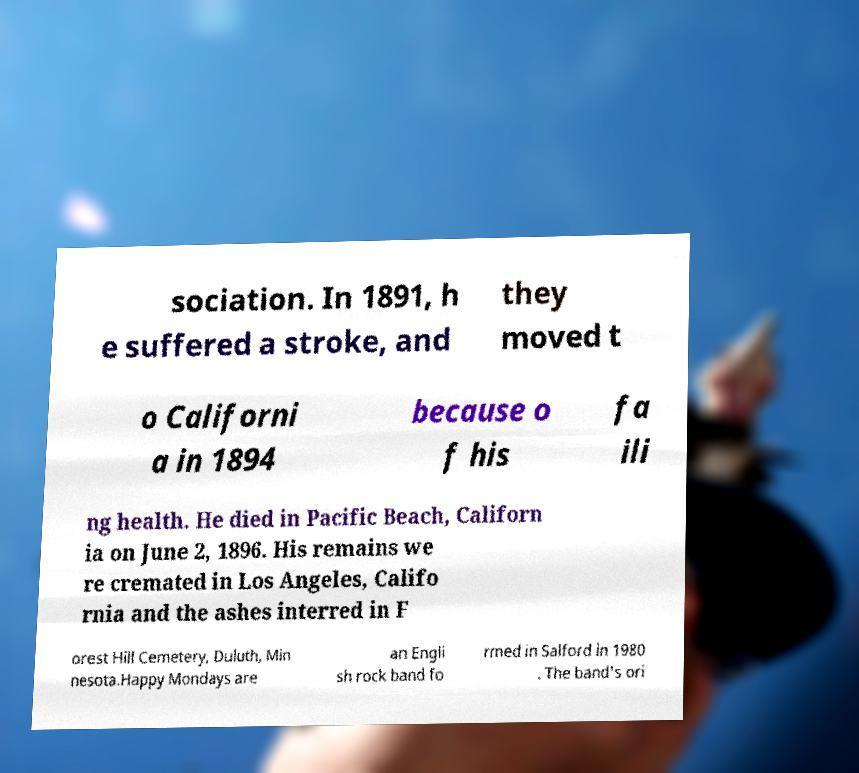There's text embedded in this image that I need extracted. Can you transcribe it verbatim? sociation. In 1891, h e suffered a stroke, and they moved t o Californi a in 1894 because o f his fa ili ng health. He died in Pacific Beach, Californ ia on June 2, 1896. His remains we re cremated in Los Angeles, Califo rnia and the ashes interred in F orest Hill Cemetery, Duluth, Min nesota.Happy Mondays are an Engli sh rock band fo rmed in Salford in 1980 . The band's ori 